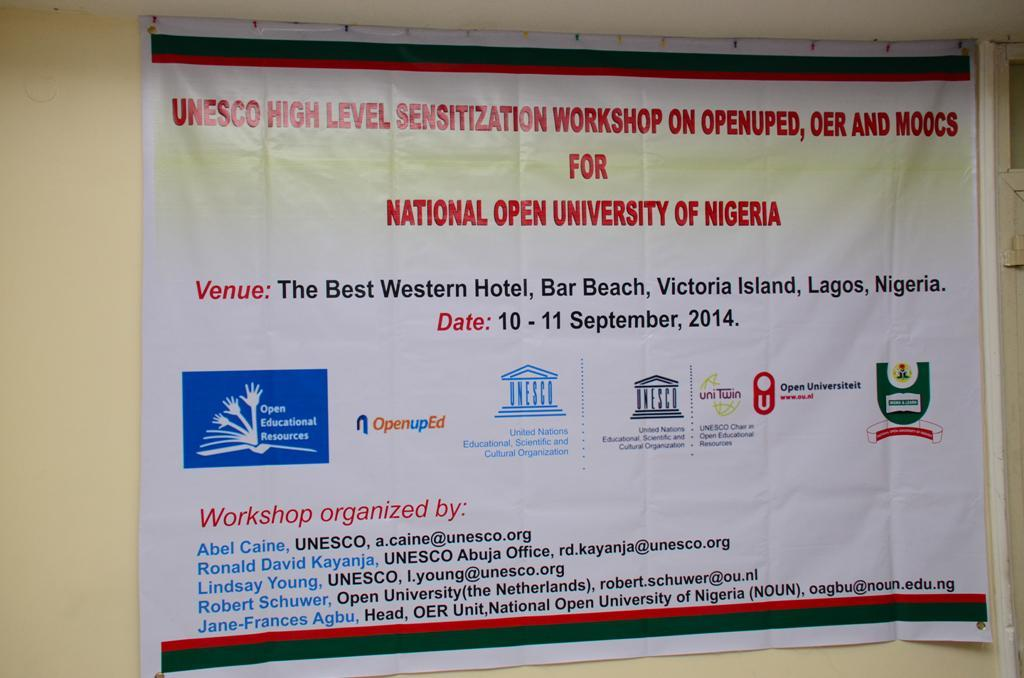<image>
Provide a brief description of the given image. A hanging banner with several different logos on the bottom and a list of workshop organizers. 